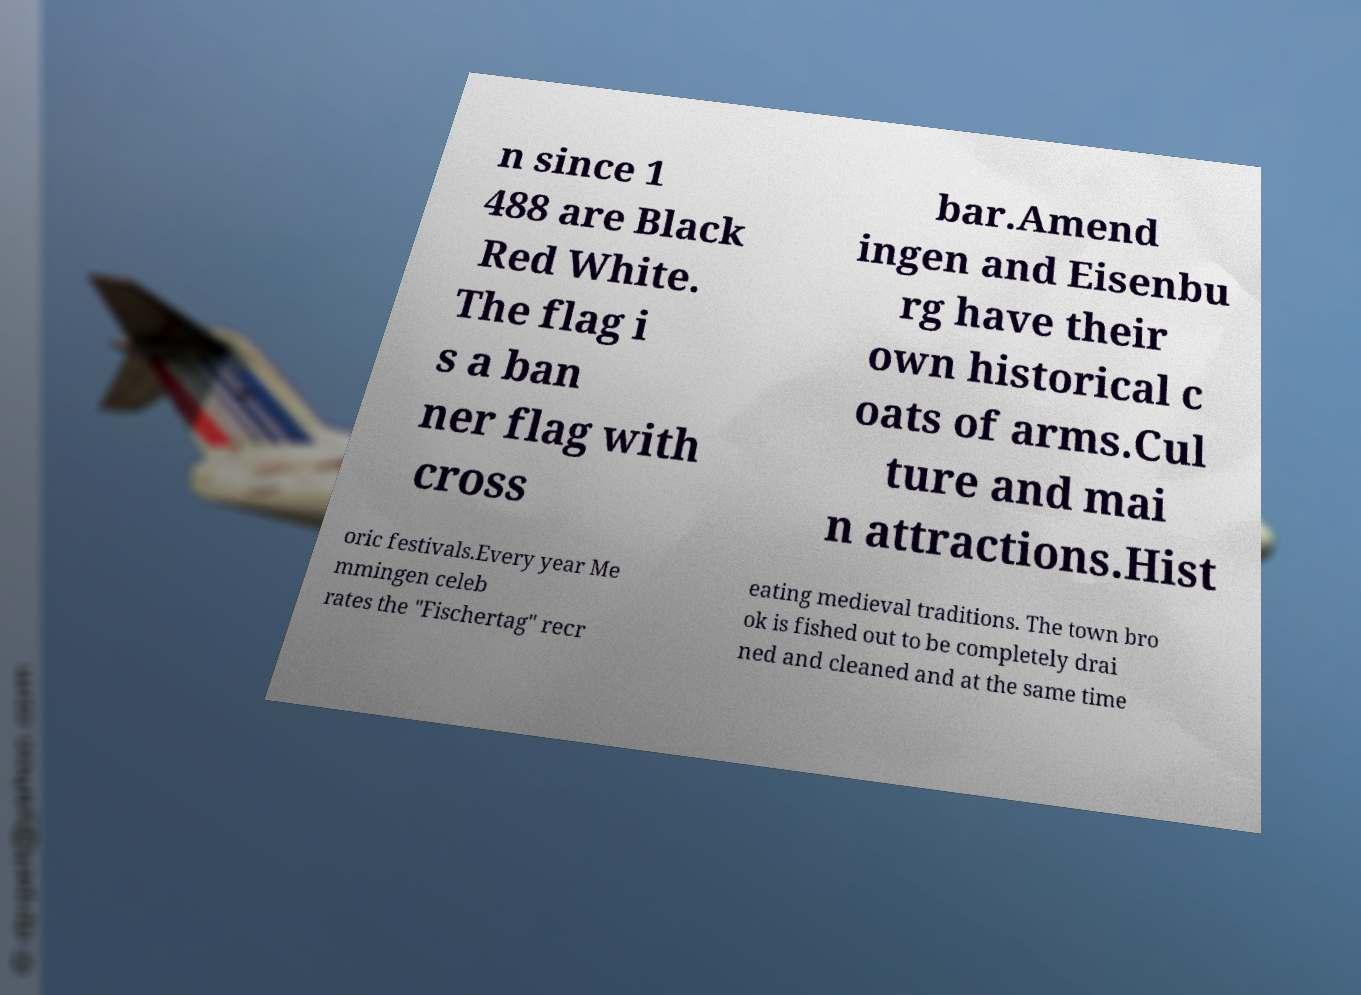What messages or text are displayed in this image? I need them in a readable, typed format. n since 1 488 are Black Red White. The flag i s a ban ner flag with cross bar.Amend ingen and Eisenbu rg have their own historical c oats of arms.Cul ture and mai n attractions.Hist oric festivals.Every year Me mmingen celeb rates the "Fischertag" recr eating medieval traditions. The town bro ok is fished out to be completely drai ned and cleaned and at the same time 